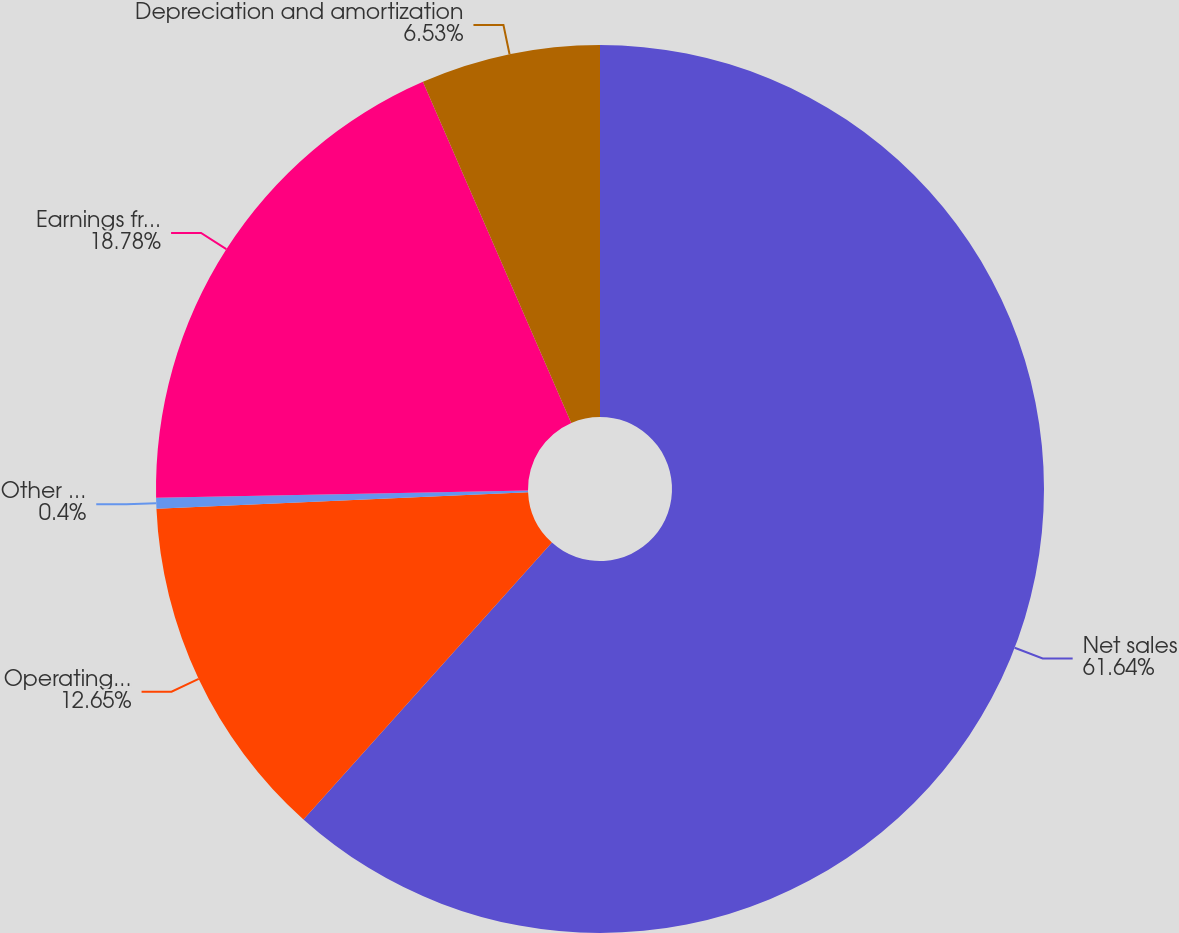<chart> <loc_0><loc_0><loc_500><loc_500><pie_chart><fcel>Net sales<fcel>Operating profit<fcel>Other (charges) gains net<fcel>Earnings from continuing<fcel>Depreciation and amortization<nl><fcel>61.64%<fcel>12.65%<fcel>0.4%<fcel>18.78%<fcel>6.53%<nl></chart> 